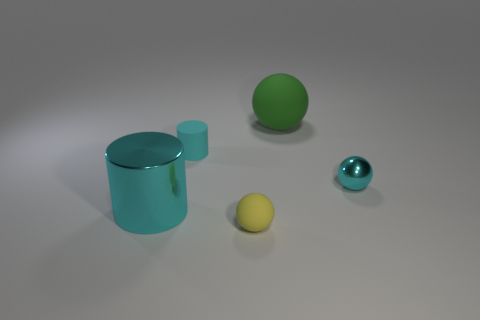Do the large shiny cylinder and the tiny matte cylinder have the same color?
Ensure brevity in your answer.  Yes. What material is the sphere that is the same color as the big metallic cylinder?
Make the answer very short. Metal. Is the material of the ball on the right side of the large matte sphere the same as the large cyan thing?
Your response must be concise. Yes. The tiny thing that is the same color as the small shiny ball is what shape?
Make the answer very short. Cylinder. Does the tiny matte thing on the left side of the small yellow ball have the same color as the tiny sphere to the right of the tiny matte ball?
Ensure brevity in your answer.  Yes. What number of matte things are behind the yellow sphere and to the right of the small cyan rubber object?
Your answer should be very brief. 1. What is the material of the tiny yellow sphere?
Offer a terse response. Rubber. What is the shape of the cyan object that is the same size as the cyan metal ball?
Offer a very short reply. Cylinder. Do the small object right of the yellow matte thing and the cyan cylinder on the left side of the rubber cylinder have the same material?
Provide a short and direct response. Yes. What number of small cyan objects are there?
Make the answer very short. 2. 